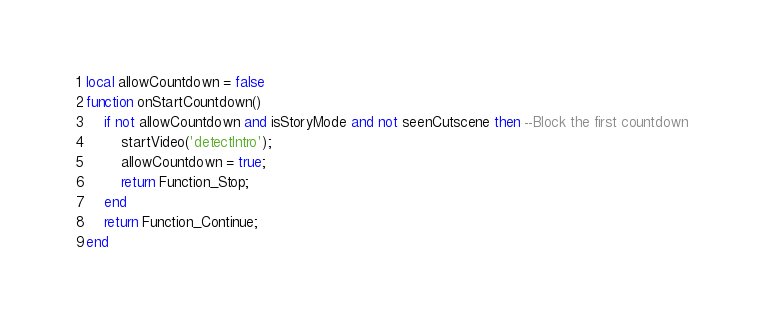<code> <loc_0><loc_0><loc_500><loc_500><_Lua_>local allowCountdown = false
function onStartCountdown()
	if not allowCountdown and isStoryMode and not seenCutscene then --Block the first countdown
		startVideo('detectIntro');
		allowCountdown = true;
		return Function_Stop;
	end
	return Function_Continue;
end</code> 